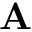<formula> <loc_0><loc_0><loc_500><loc_500>A</formula> 